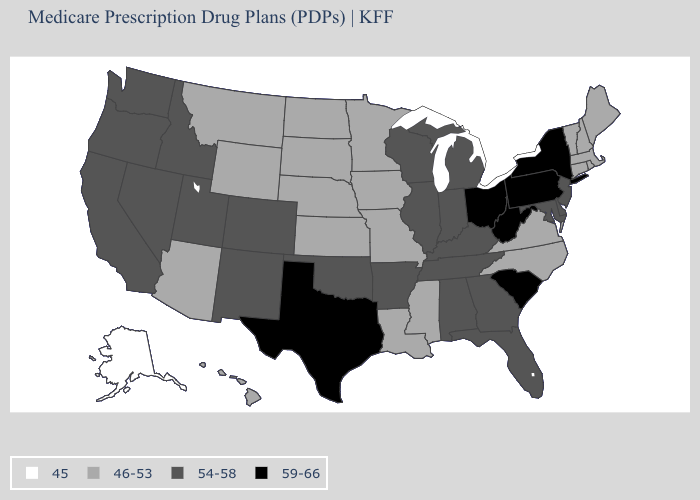Name the states that have a value in the range 54-58?
Give a very brief answer. Alabama, Arkansas, California, Colorado, Delaware, Florida, Georgia, Idaho, Illinois, Indiana, Kentucky, Maryland, Michigan, New Jersey, New Mexico, Nevada, Oklahoma, Oregon, Tennessee, Utah, Washington, Wisconsin. Name the states that have a value in the range 45?
Concise answer only. Alaska. What is the value of Rhode Island?
Be succinct. 46-53. What is the value of California?
Write a very short answer. 54-58. What is the highest value in the South ?
Be succinct. 59-66. Which states have the highest value in the USA?
Be succinct. New York, Ohio, Pennsylvania, South Carolina, Texas, West Virginia. Does Louisiana have the same value as Wyoming?
Answer briefly. Yes. How many symbols are there in the legend?
Write a very short answer. 4. What is the value of Florida?
Give a very brief answer. 54-58. What is the value of Louisiana?
Be succinct. 46-53. Name the states that have a value in the range 46-53?
Answer briefly. Arizona, Connecticut, Hawaii, Iowa, Kansas, Louisiana, Massachusetts, Maine, Minnesota, Missouri, Mississippi, Montana, North Carolina, North Dakota, Nebraska, New Hampshire, Rhode Island, South Dakota, Virginia, Vermont, Wyoming. Among the states that border California , which have the highest value?
Answer briefly. Nevada, Oregon. Does Wyoming have the same value as Pennsylvania?
Answer briefly. No. What is the lowest value in the USA?
Quick response, please. 45. What is the value of Louisiana?
Give a very brief answer. 46-53. 